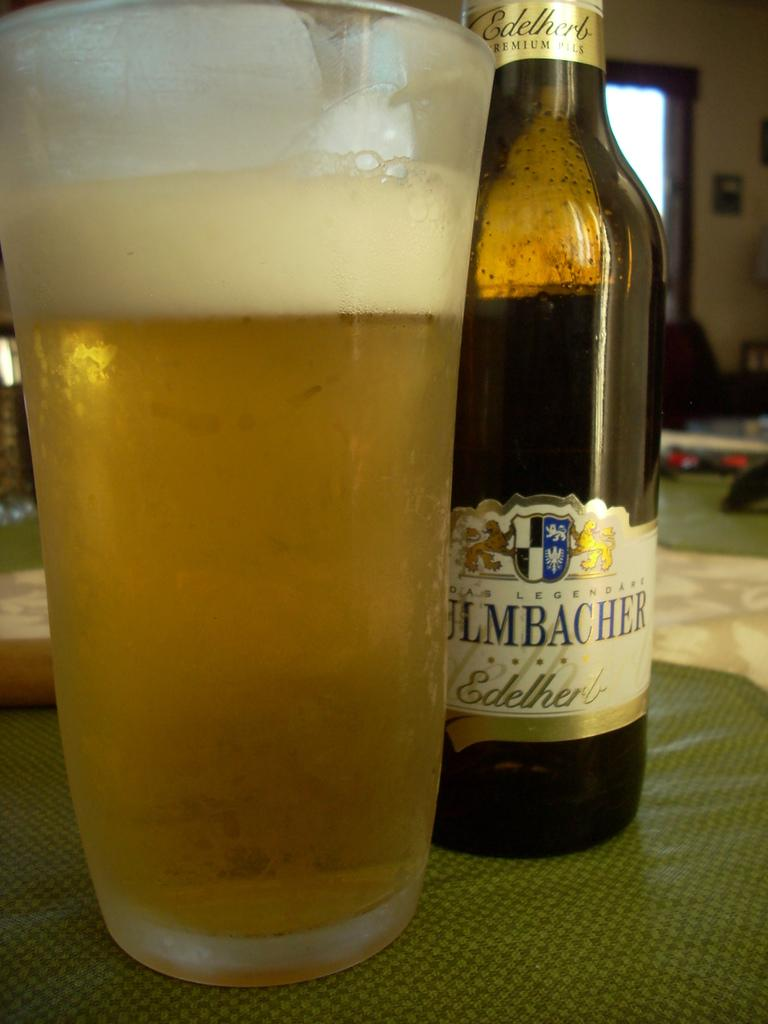<image>
Summarize the visual content of the image. A bottle of Edelherb pilsner next to a full glass of beer. 